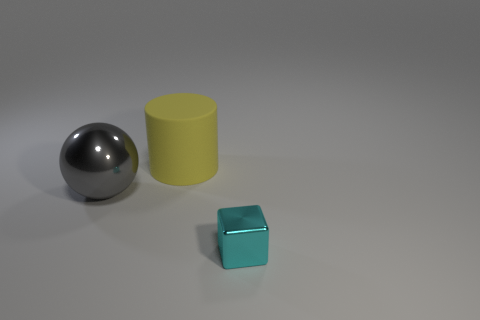Add 1 large brown matte cylinders. How many objects exist? 4 Subtract all balls. How many objects are left? 2 Add 2 big metal balls. How many big metal balls exist? 3 Subtract 0 green spheres. How many objects are left? 3 Subtract all red matte spheres. Subtract all balls. How many objects are left? 2 Add 2 spheres. How many spheres are left? 3 